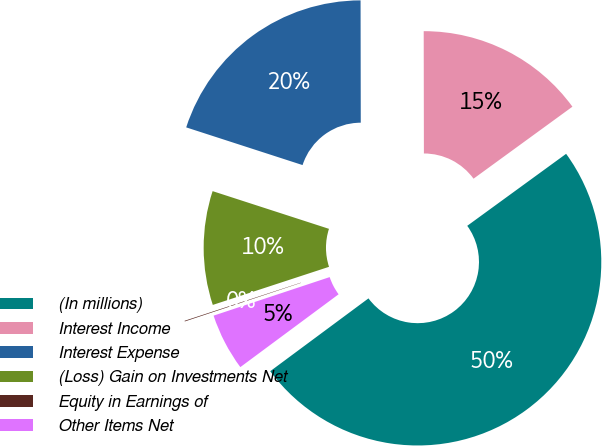<chart> <loc_0><loc_0><loc_500><loc_500><pie_chart><fcel>(In millions)<fcel>Interest Income<fcel>Interest Expense<fcel>(Loss) Gain on Investments Net<fcel>Equity in Earnings of<fcel>Other Items Net<nl><fcel>49.87%<fcel>15.01%<fcel>19.99%<fcel>10.03%<fcel>0.06%<fcel>5.05%<nl></chart> 